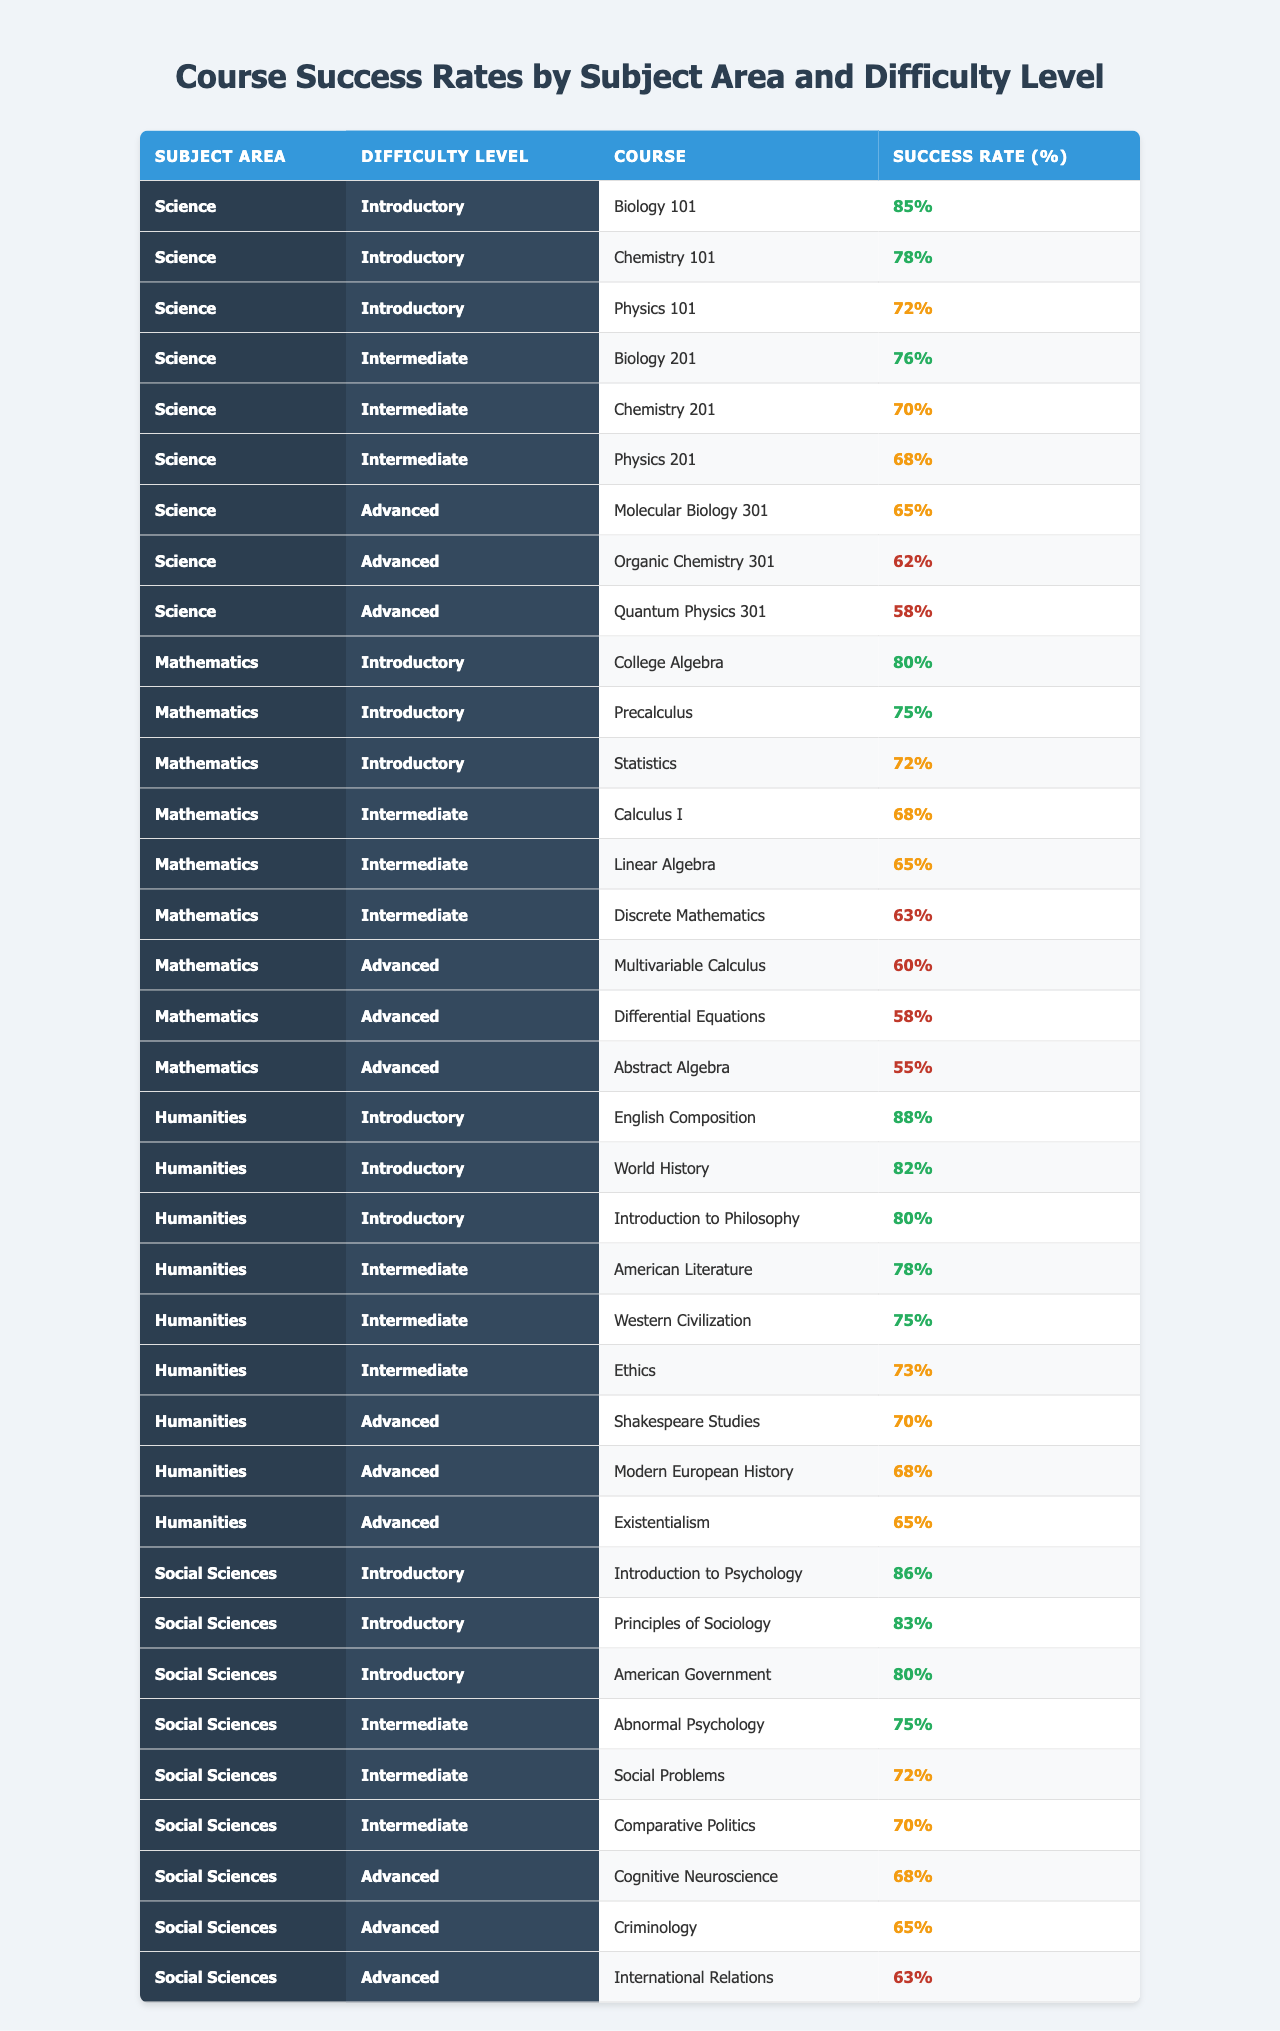What is the success rate for Biology 101? The table shows that the success rate for Biology 101 under the Science subject area and Introductory difficulty level is 85%.
Answer: 85% Which subject area has the highest success rate for Advanced level courses? Analyzing the Advanced level courses: Molecular Biology 301 (65%), Organic Chemistry 301 (62%), and Quantum Physics 301 (58%) are from the Science area. Shakespeare Studies (70%), Modern European History (68%), and Existentialism (65%) are from Humanities. The highest success rate is 70% from the Humanities.
Answer: Humanities What is the average success rate for all Intermediate level courses? The Intermediate courses from each subject area have the following success rates: Biology 201 (76%), Chemistry 201 (70%), Physics 201 (68%) for Science; Calculus I (68%), Linear Algebra (65%), Discrete Mathematics (63%) for Mathematics; Abnormal Psychology (75%), Social Problems (72%), Comparative Politics (70%) for Social Sciences; American Literature (78%), Western Civilization (75%), Ethics (73%) for Humanities. Adding them gives 76 + 70 + 68 + 68 + 65 + 63 + 75 + 72 + 70 + 78 + 75 + 73 =  863, and averaging gives 863/12 = 71.92%.
Answer: 71.92% Is the success rate for Differential Equations higher than that for Quantum Physics? Differential Equations has a success rate of 58%, while Quantum Physics has a success rate of 58% as well. Therefore, they are equal, not higher.
Answer: No Find the overall average success rate across all subjects and difficulty levels. First, add all success rates: 85 + 78 + 72 + 76 + 70 + 68 + 65 + 62 + 58 + 80 + 75 + 72 + 68 + 65 + 63 + 60 + 58 + 55 + 88 + 82 + 80 + 78 + 75 + 73 + 70 + 68 + 65 + 86 + 83 + 80 + 75 + 72 + 70 + 68 + 65 + 63 =  2178. There are 36 courses, so the average is 2178 / 36 = 60.5.
Answer: 60.5 Which subject area has the lowest success rate at the Advanced level? For Advanced courses: Science has 65%, Humanities has 70%, and Social Sciences has 68%. The lowest success rate at the Advanced level is 58% for Quantum Physics which belongs to Science.
Answer: Science What percentage of courses in the Mathematics subject area have success rates above 70%? In Mathematics, four courses have success rates above 70%: College Algebra (80%), Precalculus (75%), and Statistics (72%) out of 9 courses. The percentage is calculated as (3/9) * 100 = 33.33%.
Answer: 33.33% How many courses have a success rate below 65%? The courses with a success rate below 65% are: Quantum Physics 301 (58%), Multivariable Calculus (60%), Differential Equations (58%), and Abstract Algebra (55%). This totals to 4 courses.
Answer: 4 Are the success rates for Introductory level Mathematics courses generally higher than those for Advanced level courses? Introductory level courses have: College Algebra (80%), Precalculus (75%), and Statistics (72%), average = (80 + 75 + 72) / 3 = 75.67%. Advanced level courses have: Multivariable Calculus (60%), Differential Equations (58%), and Abstract Algebra (55%), average = (60 + 58 + 55) / 3 = 57.67%. The Introductory level average is higher than the Advanced level average.
Answer: Yes What is the highest success rate in the Introductory category across all subject areas? Scanning the Introductory level courses: Biology 101 (85%), Chemistry 101 (78%), Physics 101 (72%) in Science; College Algebra (80%), Precalculus (75%), Statistics (72%) in Mathematics; English Composition (88%), World History (82%), Introduction to Philosophy (80%) in Humanities; and Introduction to Psychology (86%), Principles of Sociology (83%), American Government (80%) in Social Sciences. The highest success rate is 88% for English Composition.
Answer: 88% 